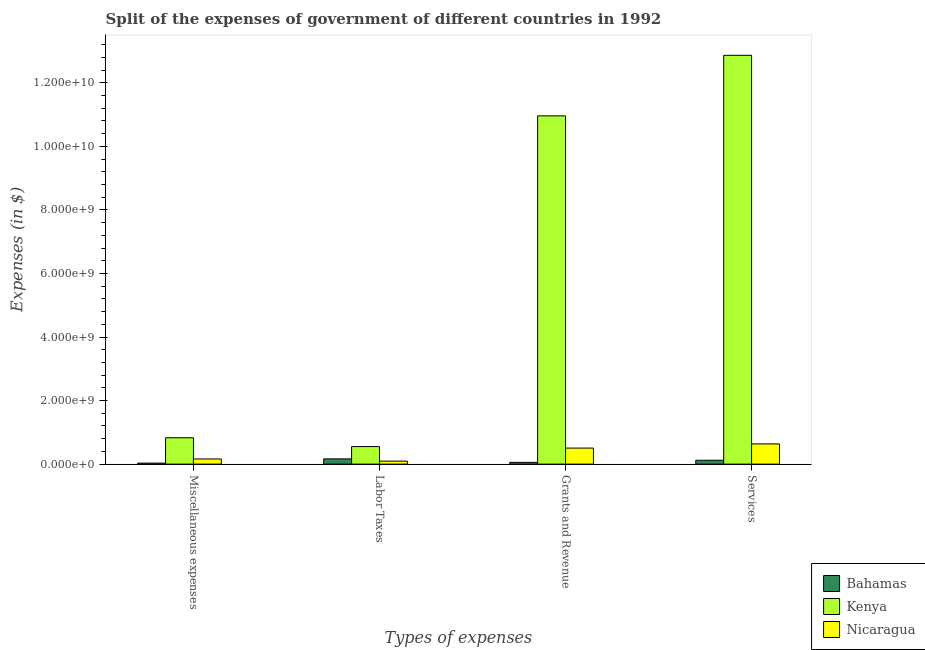How many different coloured bars are there?
Keep it short and to the point. 3. How many groups of bars are there?
Your response must be concise. 4. Are the number of bars per tick equal to the number of legend labels?
Provide a succinct answer. Yes. How many bars are there on the 1st tick from the left?
Give a very brief answer. 3. What is the label of the 2nd group of bars from the left?
Provide a short and direct response. Labor Taxes. What is the amount spent on labor taxes in Nicaragua?
Provide a short and direct response. 9.45e+07. Across all countries, what is the maximum amount spent on labor taxes?
Offer a terse response. 5.52e+08. Across all countries, what is the minimum amount spent on services?
Your response must be concise. 1.22e+08. In which country was the amount spent on labor taxes maximum?
Offer a very short reply. Kenya. In which country was the amount spent on grants and revenue minimum?
Offer a very short reply. Bahamas. What is the total amount spent on labor taxes in the graph?
Ensure brevity in your answer.  8.11e+08. What is the difference between the amount spent on miscellaneous expenses in Kenya and that in Bahamas?
Make the answer very short. 7.98e+08. What is the difference between the amount spent on miscellaneous expenses in Nicaragua and the amount spent on grants and revenue in Kenya?
Your answer should be very brief. -1.08e+1. What is the average amount spent on miscellaneous expenses per country?
Your response must be concise. 3.41e+08. What is the difference between the amount spent on grants and revenue and amount spent on labor taxes in Kenya?
Your answer should be compact. 1.04e+1. In how many countries, is the amount spent on labor taxes greater than 6800000000 $?
Your answer should be compact. 0. What is the ratio of the amount spent on labor taxes in Bahamas to that in Nicaragua?
Give a very brief answer. 1.74. Is the difference between the amount spent on labor taxes in Nicaragua and Kenya greater than the difference between the amount spent on miscellaneous expenses in Nicaragua and Kenya?
Ensure brevity in your answer.  Yes. What is the difference between the highest and the second highest amount spent on labor taxes?
Ensure brevity in your answer.  3.87e+08. What is the difference between the highest and the lowest amount spent on services?
Keep it short and to the point. 1.27e+1. In how many countries, is the amount spent on labor taxes greater than the average amount spent on labor taxes taken over all countries?
Make the answer very short. 1. Is the sum of the amount spent on labor taxes in Kenya and Nicaragua greater than the maximum amount spent on grants and revenue across all countries?
Keep it short and to the point. No. Is it the case that in every country, the sum of the amount spent on labor taxes and amount spent on miscellaneous expenses is greater than the sum of amount spent on services and amount spent on grants and revenue?
Provide a succinct answer. No. What does the 1st bar from the left in Services represents?
Your response must be concise. Bahamas. What does the 3rd bar from the right in Grants and Revenue represents?
Your response must be concise. Bahamas. Is it the case that in every country, the sum of the amount spent on miscellaneous expenses and amount spent on labor taxes is greater than the amount spent on grants and revenue?
Ensure brevity in your answer.  No. How many bars are there?
Offer a very short reply. 12. Are all the bars in the graph horizontal?
Offer a terse response. No. Are the values on the major ticks of Y-axis written in scientific E-notation?
Provide a succinct answer. Yes. Where does the legend appear in the graph?
Give a very brief answer. Bottom right. How many legend labels are there?
Your answer should be very brief. 3. What is the title of the graph?
Offer a very short reply. Split of the expenses of government of different countries in 1992. Does "Jordan" appear as one of the legend labels in the graph?
Offer a terse response. No. What is the label or title of the X-axis?
Offer a very short reply. Types of expenses. What is the label or title of the Y-axis?
Make the answer very short. Expenses (in $). What is the Expenses (in $) in Bahamas in Miscellaneous expenses?
Make the answer very short. 3.16e+07. What is the Expenses (in $) in Kenya in Miscellaneous expenses?
Keep it short and to the point. 8.30e+08. What is the Expenses (in $) in Nicaragua in Miscellaneous expenses?
Make the answer very short. 1.62e+08. What is the Expenses (in $) in Bahamas in Labor Taxes?
Provide a short and direct response. 1.65e+08. What is the Expenses (in $) in Kenya in Labor Taxes?
Make the answer very short. 5.52e+08. What is the Expenses (in $) of Nicaragua in Labor Taxes?
Make the answer very short. 9.45e+07. What is the Expenses (in $) of Bahamas in Grants and Revenue?
Make the answer very short. 5.47e+07. What is the Expenses (in $) in Kenya in Grants and Revenue?
Ensure brevity in your answer.  1.10e+1. What is the Expenses (in $) of Nicaragua in Grants and Revenue?
Give a very brief answer. 5.05e+08. What is the Expenses (in $) in Bahamas in Services?
Your answer should be very brief. 1.22e+08. What is the Expenses (in $) of Kenya in Services?
Provide a succinct answer. 1.29e+1. What is the Expenses (in $) in Nicaragua in Services?
Keep it short and to the point. 6.35e+08. Across all Types of expenses, what is the maximum Expenses (in $) in Bahamas?
Ensure brevity in your answer.  1.65e+08. Across all Types of expenses, what is the maximum Expenses (in $) of Kenya?
Your answer should be very brief. 1.29e+1. Across all Types of expenses, what is the maximum Expenses (in $) in Nicaragua?
Provide a short and direct response. 6.35e+08. Across all Types of expenses, what is the minimum Expenses (in $) of Bahamas?
Ensure brevity in your answer.  3.16e+07. Across all Types of expenses, what is the minimum Expenses (in $) of Kenya?
Your response must be concise. 5.52e+08. Across all Types of expenses, what is the minimum Expenses (in $) in Nicaragua?
Your answer should be very brief. 9.45e+07. What is the total Expenses (in $) of Bahamas in the graph?
Keep it short and to the point. 3.73e+08. What is the total Expenses (in $) in Kenya in the graph?
Provide a short and direct response. 2.52e+1. What is the total Expenses (in $) of Nicaragua in the graph?
Make the answer very short. 1.40e+09. What is the difference between the Expenses (in $) of Bahamas in Miscellaneous expenses and that in Labor Taxes?
Provide a short and direct response. -1.33e+08. What is the difference between the Expenses (in $) of Kenya in Miscellaneous expenses and that in Labor Taxes?
Your answer should be very brief. 2.78e+08. What is the difference between the Expenses (in $) of Nicaragua in Miscellaneous expenses and that in Labor Taxes?
Keep it short and to the point. 6.71e+07. What is the difference between the Expenses (in $) of Bahamas in Miscellaneous expenses and that in Grants and Revenue?
Keep it short and to the point. -2.31e+07. What is the difference between the Expenses (in $) of Kenya in Miscellaneous expenses and that in Grants and Revenue?
Keep it short and to the point. -1.01e+1. What is the difference between the Expenses (in $) of Nicaragua in Miscellaneous expenses and that in Grants and Revenue?
Your answer should be compact. -3.43e+08. What is the difference between the Expenses (in $) of Bahamas in Miscellaneous expenses and that in Services?
Provide a succinct answer. -8.99e+07. What is the difference between the Expenses (in $) of Kenya in Miscellaneous expenses and that in Services?
Ensure brevity in your answer.  -1.20e+1. What is the difference between the Expenses (in $) in Nicaragua in Miscellaneous expenses and that in Services?
Ensure brevity in your answer.  -4.73e+08. What is the difference between the Expenses (in $) of Bahamas in Labor Taxes and that in Grants and Revenue?
Offer a terse response. 1.10e+08. What is the difference between the Expenses (in $) of Kenya in Labor Taxes and that in Grants and Revenue?
Offer a very short reply. -1.04e+1. What is the difference between the Expenses (in $) of Nicaragua in Labor Taxes and that in Grants and Revenue?
Provide a short and direct response. -4.10e+08. What is the difference between the Expenses (in $) in Bahamas in Labor Taxes and that in Services?
Offer a very short reply. 4.34e+07. What is the difference between the Expenses (in $) of Kenya in Labor Taxes and that in Services?
Your answer should be very brief. -1.23e+1. What is the difference between the Expenses (in $) of Nicaragua in Labor Taxes and that in Services?
Provide a succinct answer. -5.41e+08. What is the difference between the Expenses (in $) in Bahamas in Grants and Revenue and that in Services?
Provide a short and direct response. -6.68e+07. What is the difference between the Expenses (in $) in Kenya in Grants and Revenue and that in Services?
Keep it short and to the point. -1.90e+09. What is the difference between the Expenses (in $) in Nicaragua in Grants and Revenue and that in Services?
Your response must be concise. -1.30e+08. What is the difference between the Expenses (in $) of Bahamas in Miscellaneous expenses and the Expenses (in $) of Kenya in Labor Taxes?
Keep it short and to the point. -5.20e+08. What is the difference between the Expenses (in $) in Bahamas in Miscellaneous expenses and the Expenses (in $) in Nicaragua in Labor Taxes?
Offer a terse response. -6.29e+07. What is the difference between the Expenses (in $) in Kenya in Miscellaneous expenses and the Expenses (in $) in Nicaragua in Labor Taxes?
Keep it short and to the point. 7.35e+08. What is the difference between the Expenses (in $) in Bahamas in Miscellaneous expenses and the Expenses (in $) in Kenya in Grants and Revenue?
Keep it short and to the point. -1.09e+1. What is the difference between the Expenses (in $) of Bahamas in Miscellaneous expenses and the Expenses (in $) of Nicaragua in Grants and Revenue?
Ensure brevity in your answer.  -4.73e+08. What is the difference between the Expenses (in $) of Kenya in Miscellaneous expenses and the Expenses (in $) of Nicaragua in Grants and Revenue?
Ensure brevity in your answer.  3.25e+08. What is the difference between the Expenses (in $) of Bahamas in Miscellaneous expenses and the Expenses (in $) of Kenya in Services?
Give a very brief answer. -1.28e+1. What is the difference between the Expenses (in $) in Bahamas in Miscellaneous expenses and the Expenses (in $) in Nicaragua in Services?
Offer a very short reply. -6.03e+08. What is the difference between the Expenses (in $) in Kenya in Miscellaneous expenses and the Expenses (in $) in Nicaragua in Services?
Provide a short and direct response. 1.95e+08. What is the difference between the Expenses (in $) of Bahamas in Labor Taxes and the Expenses (in $) of Kenya in Grants and Revenue?
Provide a short and direct response. -1.08e+1. What is the difference between the Expenses (in $) of Bahamas in Labor Taxes and the Expenses (in $) of Nicaragua in Grants and Revenue?
Provide a short and direct response. -3.40e+08. What is the difference between the Expenses (in $) of Kenya in Labor Taxes and the Expenses (in $) of Nicaragua in Grants and Revenue?
Make the answer very short. 4.71e+07. What is the difference between the Expenses (in $) in Bahamas in Labor Taxes and the Expenses (in $) in Kenya in Services?
Make the answer very short. -1.27e+1. What is the difference between the Expenses (in $) of Bahamas in Labor Taxes and the Expenses (in $) of Nicaragua in Services?
Your answer should be compact. -4.70e+08. What is the difference between the Expenses (in $) of Kenya in Labor Taxes and the Expenses (in $) of Nicaragua in Services?
Your response must be concise. -8.31e+07. What is the difference between the Expenses (in $) in Bahamas in Grants and Revenue and the Expenses (in $) in Kenya in Services?
Your answer should be compact. -1.28e+1. What is the difference between the Expenses (in $) in Bahamas in Grants and Revenue and the Expenses (in $) in Nicaragua in Services?
Your answer should be very brief. -5.80e+08. What is the difference between the Expenses (in $) in Kenya in Grants and Revenue and the Expenses (in $) in Nicaragua in Services?
Your answer should be very brief. 1.03e+1. What is the average Expenses (in $) in Bahamas per Types of expenses?
Give a very brief answer. 9.32e+07. What is the average Expenses (in $) of Kenya per Types of expenses?
Your answer should be compact. 6.30e+09. What is the average Expenses (in $) in Nicaragua per Types of expenses?
Your answer should be very brief. 3.49e+08. What is the difference between the Expenses (in $) in Bahamas and Expenses (in $) in Kenya in Miscellaneous expenses?
Give a very brief answer. -7.98e+08. What is the difference between the Expenses (in $) of Bahamas and Expenses (in $) of Nicaragua in Miscellaneous expenses?
Provide a short and direct response. -1.30e+08. What is the difference between the Expenses (in $) in Kenya and Expenses (in $) in Nicaragua in Miscellaneous expenses?
Your answer should be very brief. 6.68e+08. What is the difference between the Expenses (in $) in Bahamas and Expenses (in $) in Kenya in Labor Taxes?
Your answer should be very brief. -3.87e+08. What is the difference between the Expenses (in $) in Bahamas and Expenses (in $) in Nicaragua in Labor Taxes?
Offer a terse response. 7.04e+07. What is the difference between the Expenses (in $) of Kenya and Expenses (in $) of Nicaragua in Labor Taxes?
Provide a short and direct response. 4.57e+08. What is the difference between the Expenses (in $) of Bahamas and Expenses (in $) of Kenya in Grants and Revenue?
Offer a terse response. -1.09e+1. What is the difference between the Expenses (in $) in Bahamas and Expenses (in $) in Nicaragua in Grants and Revenue?
Offer a terse response. -4.50e+08. What is the difference between the Expenses (in $) of Kenya and Expenses (in $) of Nicaragua in Grants and Revenue?
Give a very brief answer. 1.05e+1. What is the difference between the Expenses (in $) in Bahamas and Expenses (in $) in Kenya in Services?
Keep it short and to the point. -1.27e+1. What is the difference between the Expenses (in $) of Bahamas and Expenses (in $) of Nicaragua in Services?
Offer a terse response. -5.14e+08. What is the difference between the Expenses (in $) of Kenya and Expenses (in $) of Nicaragua in Services?
Your answer should be compact. 1.22e+1. What is the ratio of the Expenses (in $) of Bahamas in Miscellaneous expenses to that in Labor Taxes?
Keep it short and to the point. 0.19. What is the ratio of the Expenses (in $) of Kenya in Miscellaneous expenses to that in Labor Taxes?
Give a very brief answer. 1.5. What is the ratio of the Expenses (in $) in Nicaragua in Miscellaneous expenses to that in Labor Taxes?
Make the answer very short. 1.71. What is the ratio of the Expenses (in $) of Bahamas in Miscellaneous expenses to that in Grants and Revenue?
Your answer should be very brief. 0.58. What is the ratio of the Expenses (in $) in Kenya in Miscellaneous expenses to that in Grants and Revenue?
Provide a short and direct response. 0.08. What is the ratio of the Expenses (in $) of Nicaragua in Miscellaneous expenses to that in Grants and Revenue?
Your answer should be very brief. 0.32. What is the ratio of the Expenses (in $) of Bahamas in Miscellaneous expenses to that in Services?
Ensure brevity in your answer.  0.26. What is the ratio of the Expenses (in $) of Kenya in Miscellaneous expenses to that in Services?
Give a very brief answer. 0.06. What is the ratio of the Expenses (in $) in Nicaragua in Miscellaneous expenses to that in Services?
Your answer should be compact. 0.25. What is the ratio of the Expenses (in $) in Bahamas in Labor Taxes to that in Grants and Revenue?
Offer a very short reply. 3.01. What is the ratio of the Expenses (in $) in Kenya in Labor Taxes to that in Grants and Revenue?
Provide a short and direct response. 0.05. What is the ratio of the Expenses (in $) of Nicaragua in Labor Taxes to that in Grants and Revenue?
Offer a terse response. 0.19. What is the ratio of the Expenses (in $) of Bahamas in Labor Taxes to that in Services?
Ensure brevity in your answer.  1.36. What is the ratio of the Expenses (in $) in Kenya in Labor Taxes to that in Services?
Your answer should be compact. 0.04. What is the ratio of the Expenses (in $) in Nicaragua in Labor Taxes to that in Services?
Keep it short and to the point. 0.15. What is the ratio of the Expenses (in $) in Bahamas in Grants and Revenue to that in Services?
Your answer should be compact. 0.45. What is the ratio of the Expenses (in $) in Kenya in Grants and Revenue to that in Services?
Provide a succinct answer. 0.85. What is the ratio of the Expenses (in $) in Nicaragua in Grants and Revenue to that in Services?
Your answer should be compact. 0.8. What is the difference between the highest and the second highest Expenses (in $) in Bahamas?
Provide a short and direct response. 4.34e+07. What is the difference between the highest and the second highest Expenses (in $) of Kenya?
Your answer should be compact. 1.90e+09. What is the difference between the highest and the second highest Expenses (in $) of Nicaragua?
Ensure brevity in your answer.  1.30e+08. What is the difference between the highest and the lowest Expenses (in $) of Bahamas?
Provide a succinct answer. 1.33e+08. What is the difference between the highest and the lowest Expenses (in $) of Kenya?
Your answer should be compact. 1.23e+1. What is the difference between the highest and the lowest Expenses (in $) of Nicaragua?
Your answer should be very brief. 5.41e+08. 